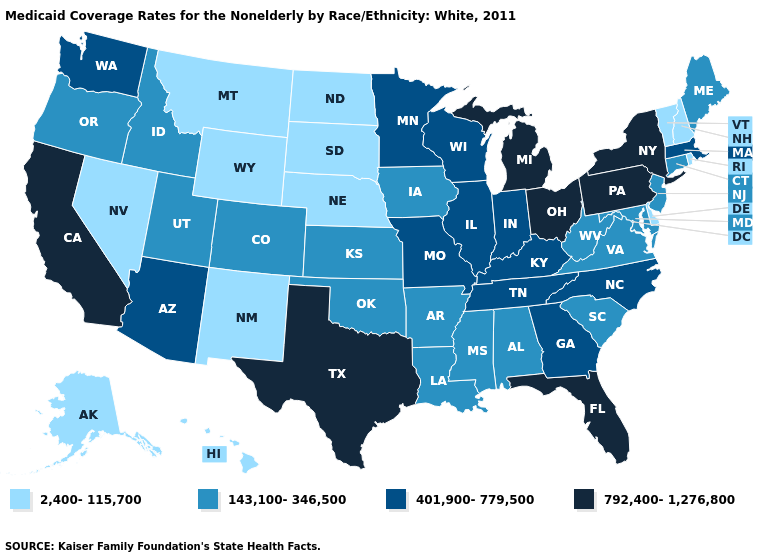Does Maine have the highest value in the Northeast?
Give a very brief answer. No. Among the states that border Virginia , does Kentucky have the lowest value?
Quick response, please. No. Name the states that have a value in the range 792,400-1,276,800?
Quick response, please. California, Florida, Michigan, New York, Ohio, Pennsylvania, Texas. What is the value of Wyoming?
Write a very short answer. 2,400-115,700. Which states hav the highest value in the South?
Be succinct. Florida, Texas. What is the highest value in the Northeast ?
Give a very brief answer. 792,400-1,276,800. Among the states that border Virginia , which have the highest value?
Quick response, please. Kentucky, North Carolina, Tennessee. Is the legend a continuous bar?
Be succinct. No. Does Delaware have the lowest value in the South?
Be succinct. Yes. Does Alaska have a lower value than Pennsylvania?
Give a very brief answer. Yes. What is the value of West Virginia?
Write a very short answer. 143,100-346,500. Name the states that have a value in the range 401,900-779,500?
Short answer required. Arizona, Georgia, Illinois, Indiana, Kentucky, Massachusetts, Minnesota, Missouri, North Carolina, Tennessee, Washington, Wisconsin. What is the lowest value in states that border Pennsylvania?
Concise answer only. 2,400-115,700. Among the states that border Oklahoma , does Colorado have the highest value?
Quick response, please. No. 